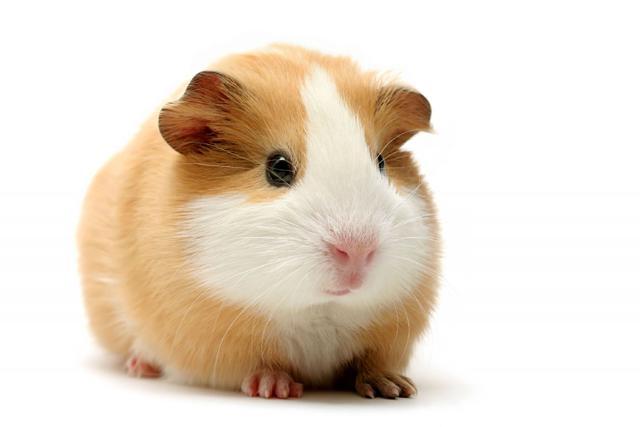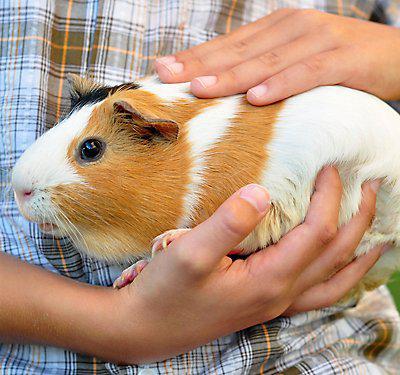The first image is the image on the left, the second image is the image on the right. Examine the images to the left and right. Is the description "At least one of the animals is sitting on a soft cushioned material." accurate? Answer yes or no. No. 